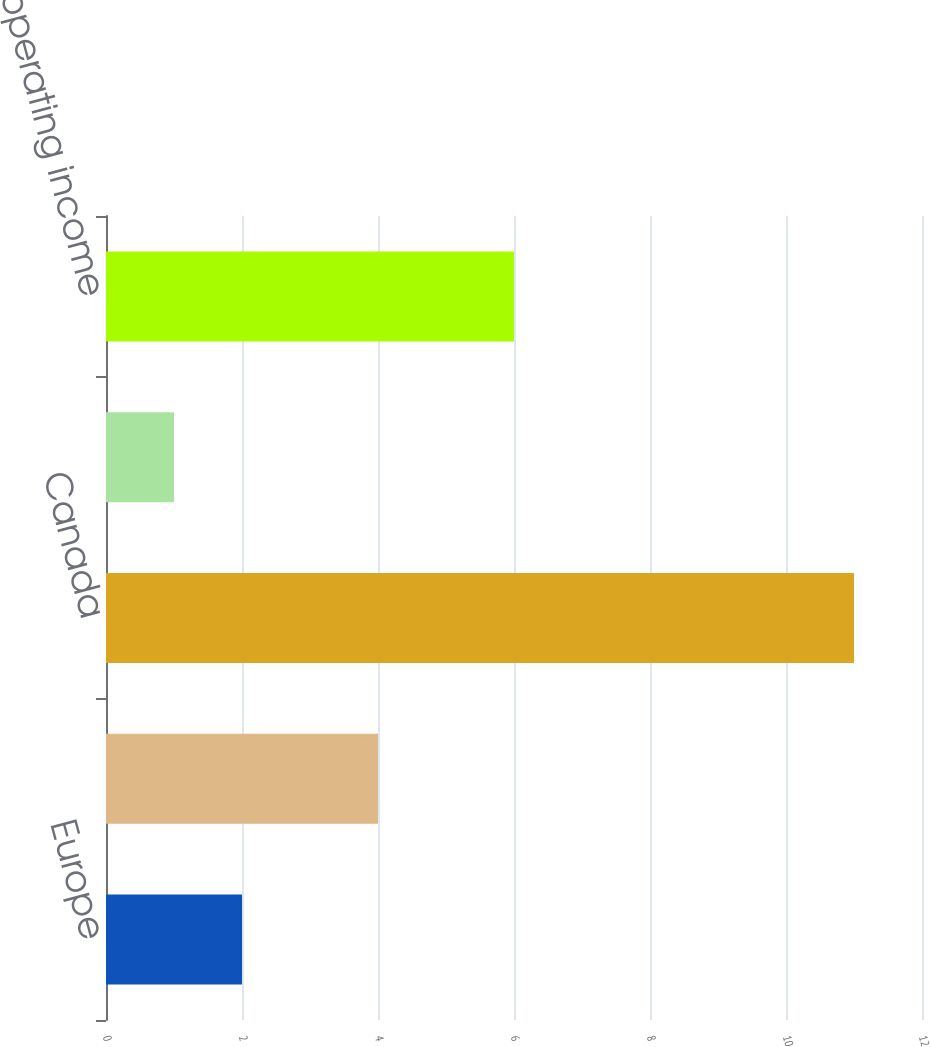Convert chart. <chart><loc_0><loc_0><loc_500><loc_500><bar_chart><fcel>Europe<fcel>Latin America<fcel>Canada<fcel>Total operating revenue<fcel>Total operating income<nl><fcel>2<fcel>4<fcel>11<fcel>1<fcel>6<nl></chart> 